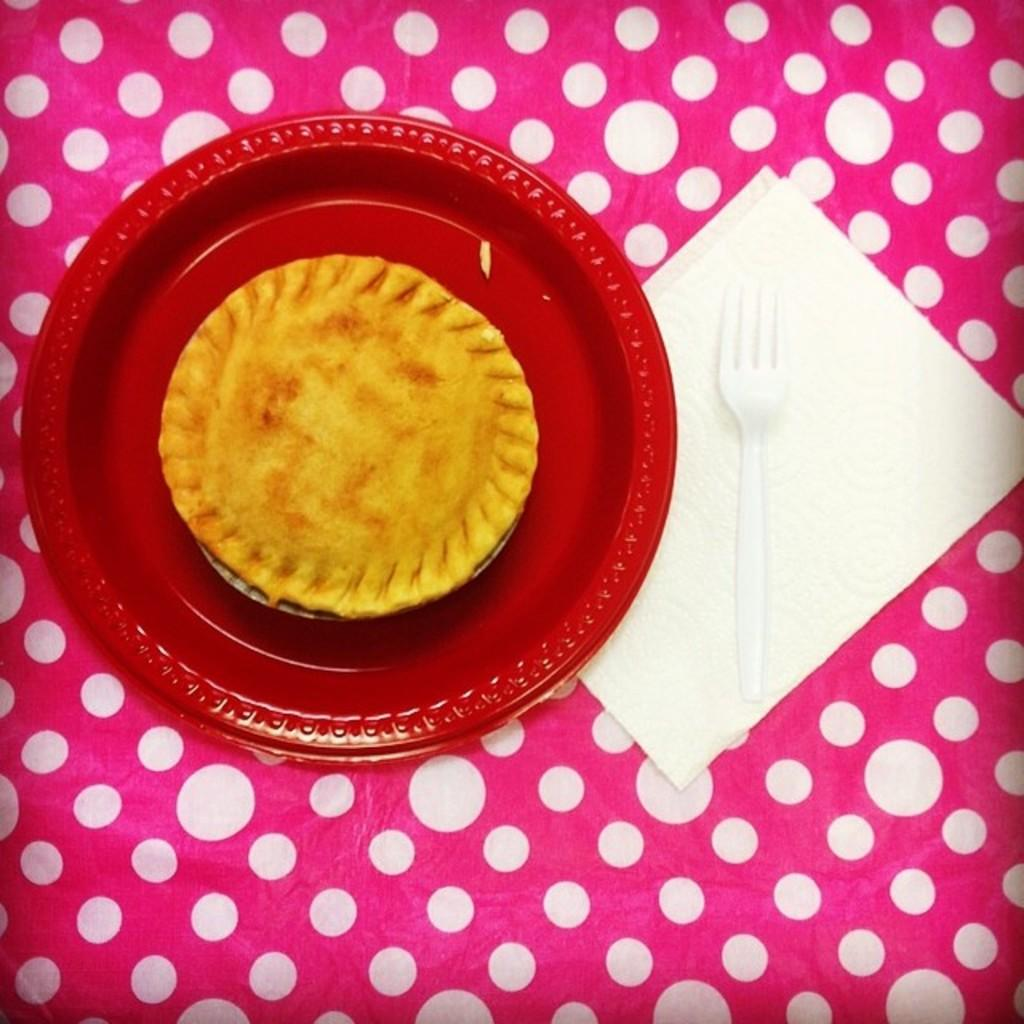What is the main object in the image? There is a red color palette in the image. What is on the palette? The palette contains a food item. What is the food item placed on? The food item is placed on a pink color object. What utensil can be seen in the image? There is a fork visible in the image. What item might be used for cleaning or wiping in the image? There is a tissue paper in the image. What type of treatment is being administered to the food item in the image? There is no treatment being administered to the food item in the image; it is simply placed on the palette. 